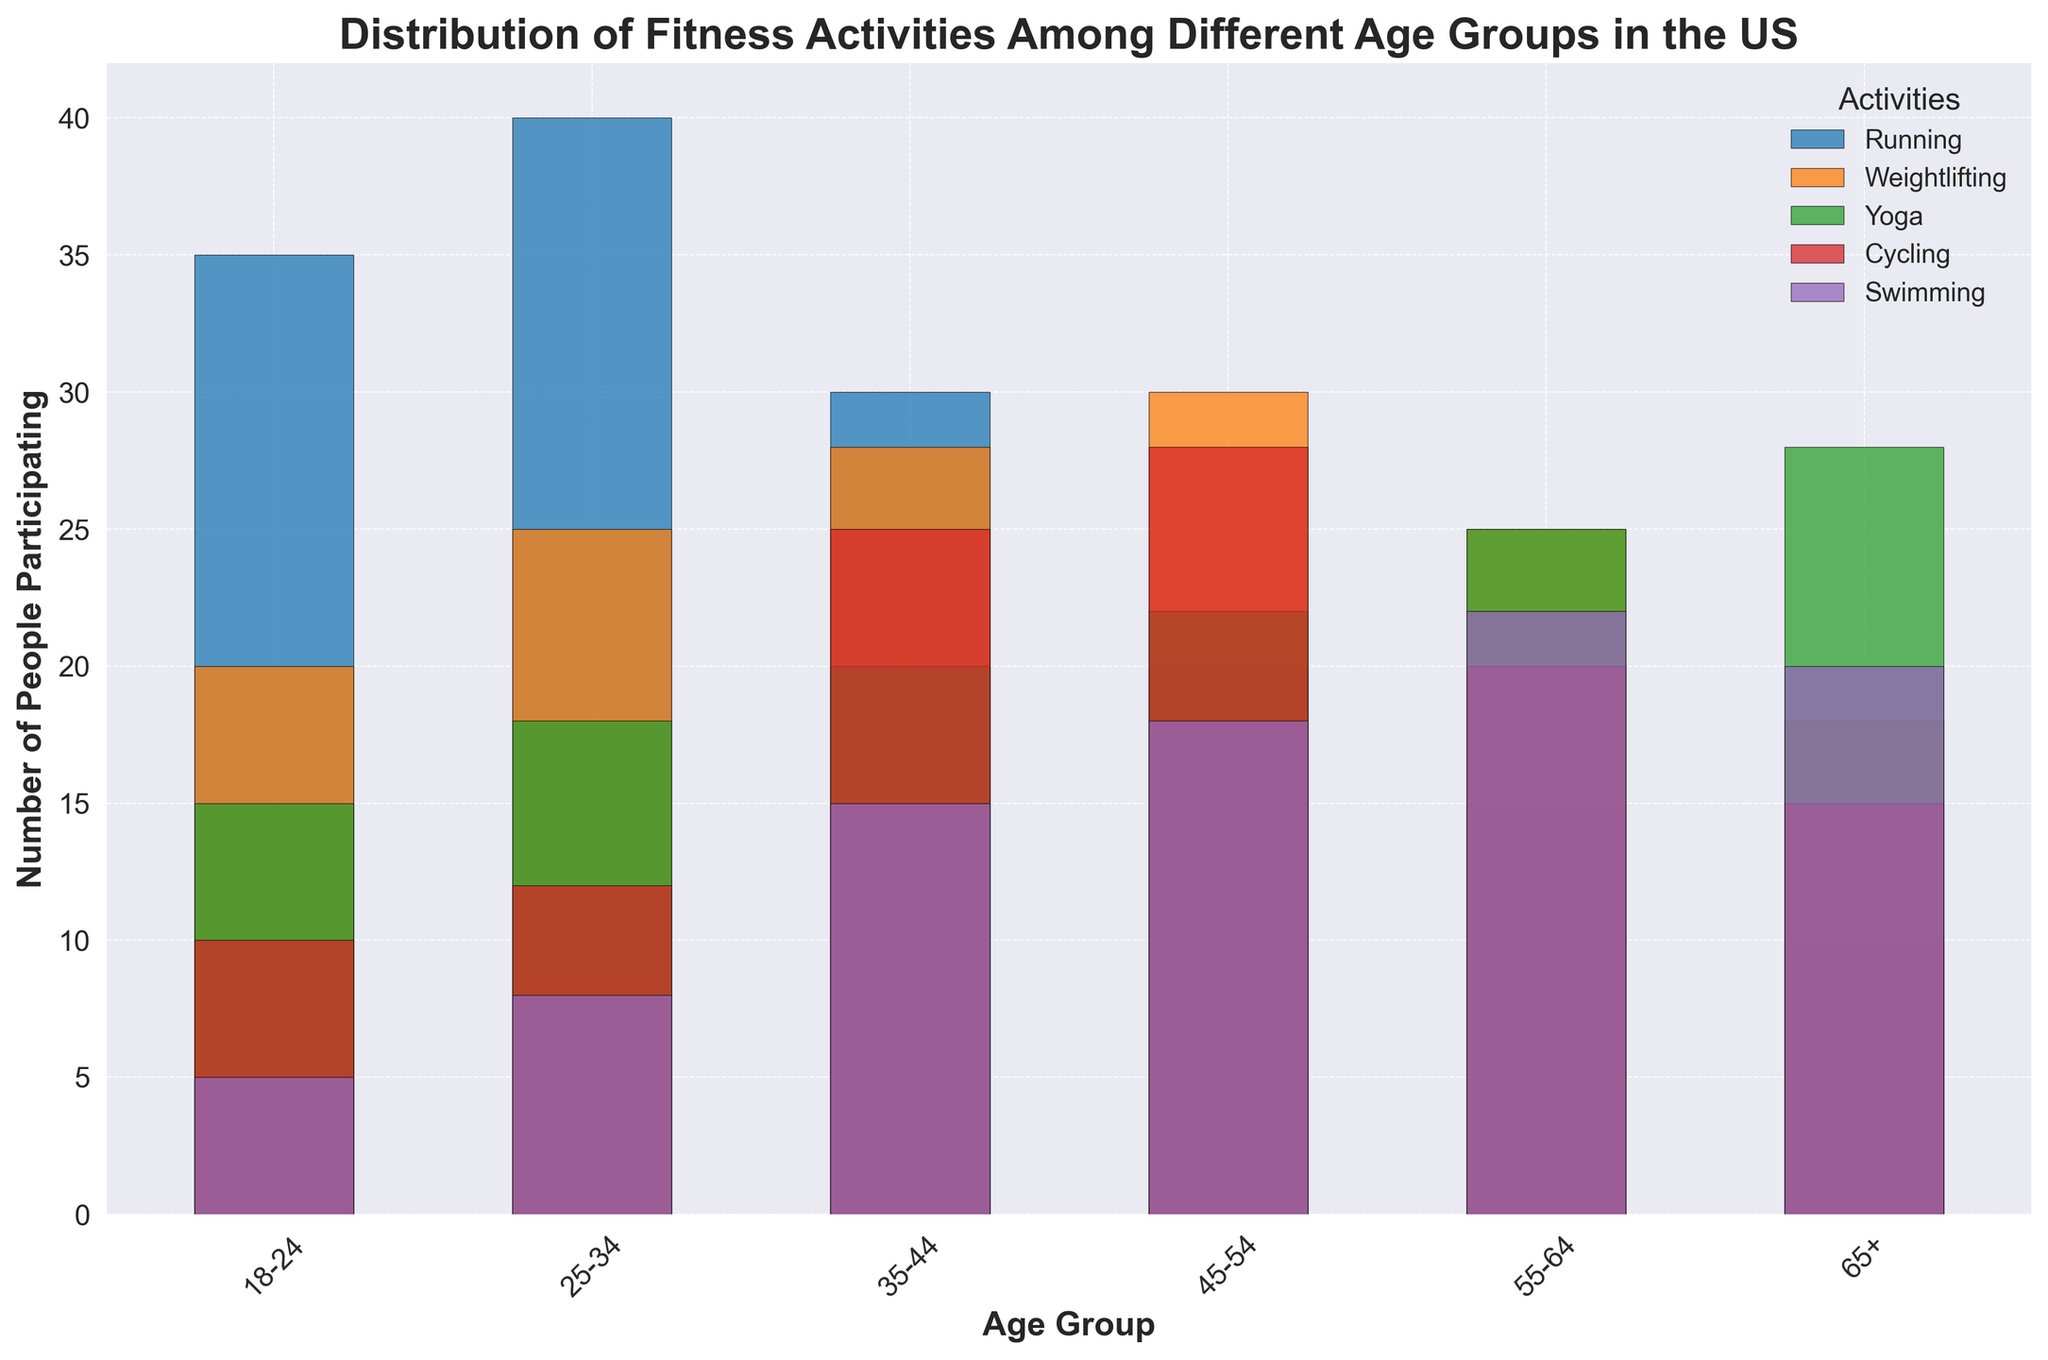What's the most popular fitness activity for the 35-44 age group? To determine the most popular activity, look at the bars corresponding to the 35-44 age group and identify which one is the tallest. The tallest bar for this age group represents cycling, indicating it is the most popular activity.
Answer: Cycling Which age group has the highest number of people doing weightlifting? Examine the bars for weightlifting across all age groups and find the tallest one. The tallest bar for weightlifting appears in the 45-54 age group.
Answer: 45-54 By how much does the number of people doing yoga differ between the 18-24 and 65+ age groups? Look at the heights of the bars for yoga in the 18-24 and 65+ age groups. Subtract the smaller number (for the 18-24 age group) from the larger number (for the 65+ age group). The bar for 65+ is 28, and for 18-24 is 15, so the difference is 28 - 15 = 13.
Answer: 13 What is the average number of people participating in swimming across all age groups? Sum the numbers for swimming across all age groups and divide by the total number of age groups. The values are 5 + 8 + 15 + 18 + 22 + 20 = 88. There are 6 age groups. 88/6 ≈ 14.67.
Answer: 14.67 Which fitness activity surpasses 20 participants in only the 45-54 and 55-64 age groups? Identify the activities that have bars exceeding 20 participants in specifically the 45-54 and 55-64 age groups, excluding other age groups. Weightlifting (30, 25) and Yoga (22, 25) fit this criterion, but Yoga is the one meeting 20 participants exactly.
Answer: Yoga Is running more popular in older or younger age groups? Compare the heights of the bars for running across different age groups. Higher bars in younger age groups (18-24, 25-34) indicate it is more popular among younger people.
Answer: Younger Which activity shows the least variation in the number of participants across all age groups? To find the activity with the least variation, look for the smallest differences in bar heights across age groups. Weightlifting shows relatively consistent bar heights compared to other activities.
Answer: Weightlifting What is the total number of participants for cycling in the 35-44 and 45-54 age groups combined? Add the number of people participating in cycling for these two age groups. Cycling for 35-44 is 25, and for 45-54 is 28. The total is 25 + 28 = 53.
Answer: 53 Which has more participants: swimming in the 55-64 age group or weightlifting in the 18-24 age group? Compare the bars for swimming in the 55-64 age group and weightlifting in the 18-24 age group. Swimming (22) has more participants than weightlifting (20) in their respective age groups.
Answer: Swimming in the 55-64 age group 